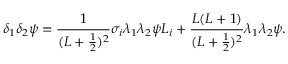<formula> <loc_0><loc_0><loc_500><loc_500>\delta _ { 1 } \delta _ { 2 } \psi = \frac { 1 } { ( L + \frac { 1 } { 2 } ) ^ { 2 } } \sigma _ { i } \lambda _ { 1 } \lambda _ { 2 } \psi L _ { i } + \frac { L ( L + 1 ) } { ( L + \frac { 1 } { 2 } ) ^ { 2 } } \lambda _ { 1 } \lambda _ { 2 } \psi .</formula> 